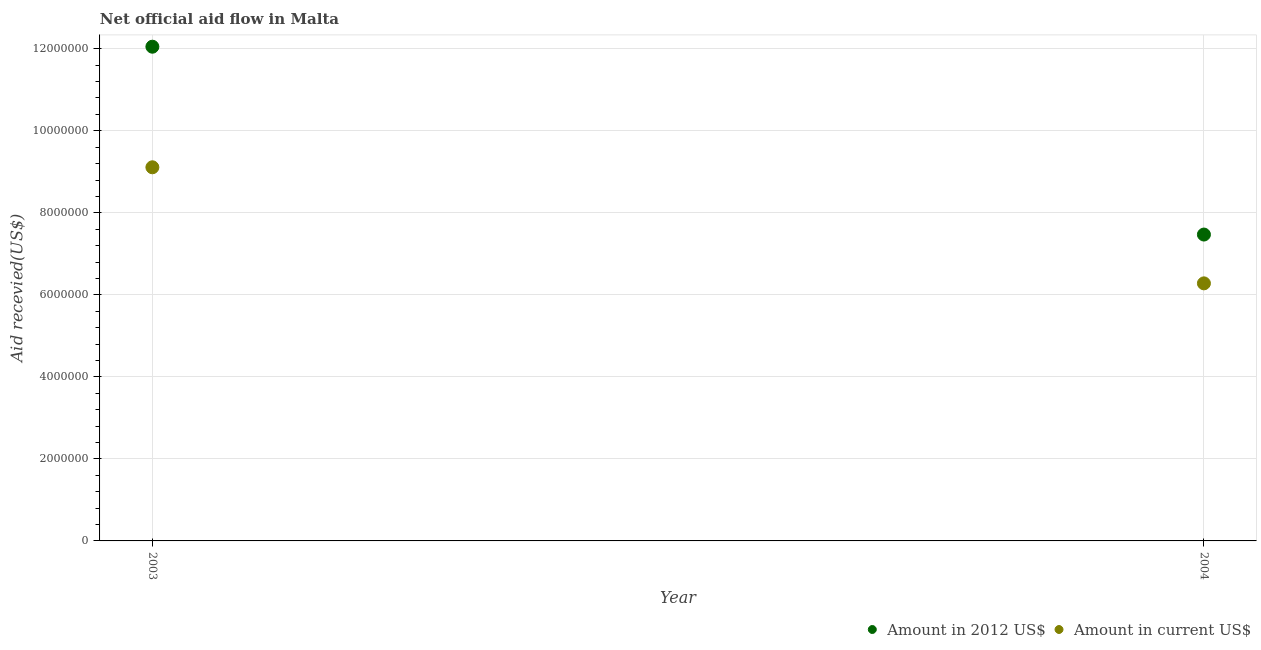How many different coloured dotlines are there?
Give a very brief answer. 2. Is the number of dotlines equal to the number of legend labels?
Ensure brevity in your answer.  Yes. What is the amount of aid received(expressed in 2012 us$) in 2004?
Offer a terse response. 7.47e+06. Across all years, what is the maximum amount of aid received(expressed in 2012 us$)?
Ensure brevity in your answer.  1.20e+07. Across all years, what is the minimum amount of aid received(expressed in 2012 us$)?
Offer a terse response. 7.47e+06. In which year was the amount of aid received(expressed in 2012 us$) maximum?
Give a very brief answer. 2003. In which year was the amount of aid received(expressed in 2012 us$) minimum?
Provide a short and direct response. 2004. What is the total amount of aid received(expressed in 2012 us$) in the graph?
Give a very brief answer. 1.95e+07. What is the difference between the amount of aid received(expressed in us$) in 2003 and that in 2004?
Offer a very short reply. 2.83e+06. What is the difference between the amount of aid received(expressed in 2012 us$) in 2003 and the amount of aid received(expressed in us$) in 2004?
Give a very brief answer. 5.77e+06. What is the average amount of aid received(expressed in 2012 us$) per year?
Ensure brevity in your answer.  9.76e+06. In the year 2004, what is the difference between the amount of aid received(expressed in us$) and amount of aid received(expressed in 2012 us$)?
Provide a succinct answer. -1.19e+06. What is the ratio of the amount of aid received(expressed in 2012 us$) in 2003 to that in 2004?
Ensure brevity in your answer.  1.61. Is the amount of aid received(expressed in us$) in 2003 less than that in 2004?
Provide a short and direct response. No. Is the amount of aid received(expressed in 2012 us$) strictly greater than the amount of aid received(expressed in us$) over the years?
Make the answer very short. Yes. Is the amount of aid received(expressed in 2012 us$) strictly less than the amount of aid received(expressed in us$) over the years?
Your response must be concise. No. How many dotlines are there?
Make the answer very short. 2. How many years are there in the graph?
Offer a very short reply. 2. What is the difference between two consecutive major ticks on the Y-axis?
Your answer should be very brief. 2.00e+06. Does the graph contain any zero values?
Provide a short and direct response. No. Where does the legend appear in the graph?
Provide a short and direct response. Bottom right. How many legend labels are there?
Keep it short and to the point. 2. What is the title of the graph?
Give a very brief answer. Net official aid flow in Malta. Does "Highest 20% of population" appear as one of the legend labels in the graph?
Offer a very short reply. No. What is the label or title of the Y-axis?
Your answer should be compact. Aid recevied(US$). What is the Aid recevied(US$) in Amount in 2012 US$ in 2003?
Offer a terse response. 1.20e+07. What is the Aid recevied(US$) of Amount in current US$ in 2003?
Offer a terse response. 9.11e+06. What is the Aid recevied(US$) of Amount in 2012 US$ in 2004?
Ensure brevity in your answer.  7.47e+06. What is the Aid recevied(US$) of Amount in current US$ in 2004?
Your answer should be very brief. 6.28e+06. Across all years, what is the maximum Aid recevied(US$) of Amount in 2012 US$?
Keep it short and to the point. 1.20e+07. Across all years, what is the maximum Aid recevied(US$) in Amount in current US$?
Make the answer very short. 9.11e+06. Across all years, what is the minimum Aid recevied(US$) of Amount in 2012 US$?
Offer a terse response. 7.47e+06. Across all years, what is the minimum Aid recevied(US$) in Amount in current US$?
Ensure brevity in your answer.  6.28e+06. What is the total Aid recevied(US$) in Amount in 2012 US$ in the graph?
Your answer should be compact. 1.95e+07. What is the total Aid recevied(US$) of Amount in current US$ in the graph?
Give a very brief answer. 1.54e+07. What is the difference between the Aid recevied(US$) in Amount in 2012 US$ in 2003 and that in 2004?
Keep it short and to the point. 4.58e+06. What is the difference between the Aid recevied(US$) of Amount in current US$ in 2003 and that in 2004?
Ensure brevity in your answer.  2.83e+06. What is the difference between the Aid recevied(US$) in Amount in 2012 US$ in 2003 and the Aid recevied(US$) in Amount in current US$ in 2004?
Provide a succinct answer. 5.77e+06. What is the average Aid recevied(US$) in Amount in 2012 US$ per year?
Keep it short and to the point. 9.76e+06. What is the average Aid recevied(US$) of Amount in current US$ per year?
Your answer should be very brief. 7.70e+06. In the year 2003, what is the difference between the Aid recevied(US$) of Amount in 2012 US$ and Aid recevied(US$) of Amount in current US$?
Your answer should be very brief. 2.94e+06. In the year 2004, what is the difference between the Aid recevied(US$) in Amount in 2012 US$ and Aid recevied(US$) in Amount in current US$?
Provide a succinct answer. 1.19e+06. What is the ratio of the Aid recevied(US$) of Amount in 2012 US$ in 2003 to that in 2004?
Provide a succinct answer. 1.61. What is the ratio of the Aid recevied(US$) in Amount in current US$ in 2003 to that in 2004?
Offer a terse response. 1.45. What is the difference between the highest and the second highest Aid recevied(US$) in Amount in 2012 US$?
Ensure brevity in your answer.  4.58e+06. What is the difference between the highest and the second highest Aid recevied(US$) of Amount in current US$?
Give a very brief answer. 2.83e+06. What is the difference between the highest and the lowest Aid recevied(US$) of Amount in 2012 US$?
Offer a terse response. 4.58e+06. What is the difference between the highest and the lowest Aid recevied(US$) of Amount in current US$?
Keep it short and to the point. 2.83e+06. 